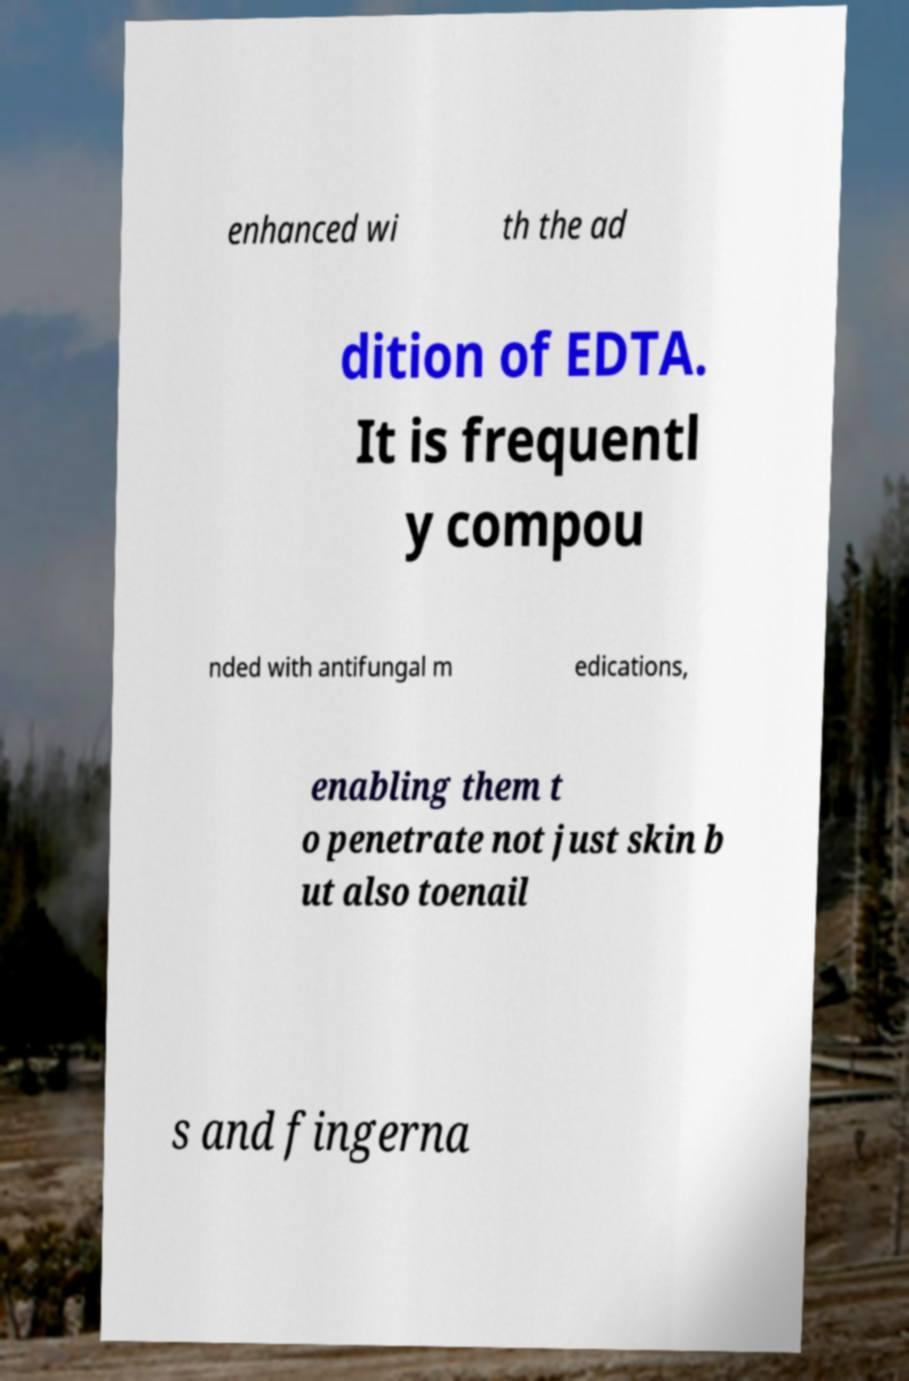Can you accurately transcribe the text from the provided image for me? enhanced wi th the ad dition of EDTA. It is frequentl y compou nded with antifungal m edications, enabling them t o penetrate not just skin b ut also toenail s and fingerna 